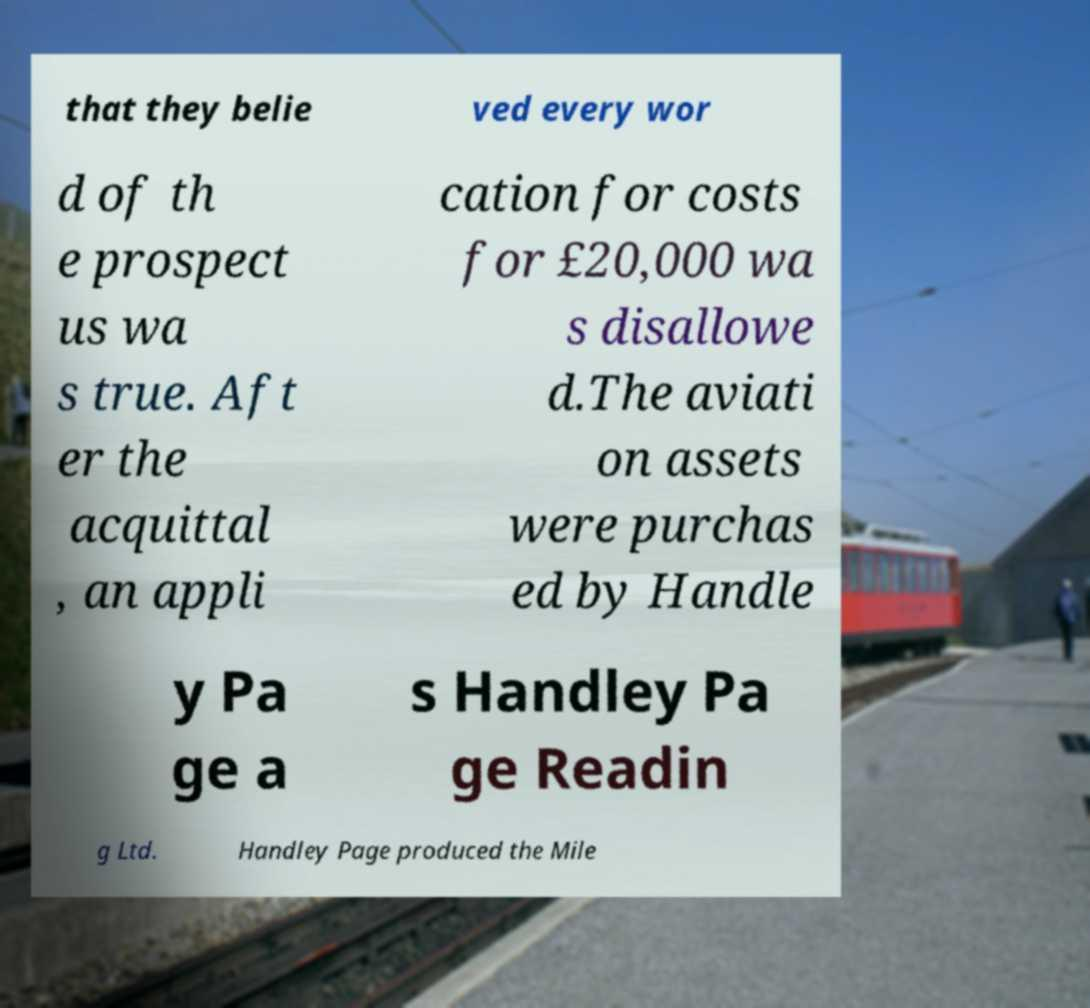I need the written content from this picture converted into text. Can you do that? that they belie ved every wor d of th e prospect us wa s true. Aft er the acquittal , an appli cation for costs for £20,000 wa s disallowe d.The aviati on assets were purchas ed by Handle y Pa ge a s Handley Pa ge Readin g Ltd. Handley Page produced the Mile 